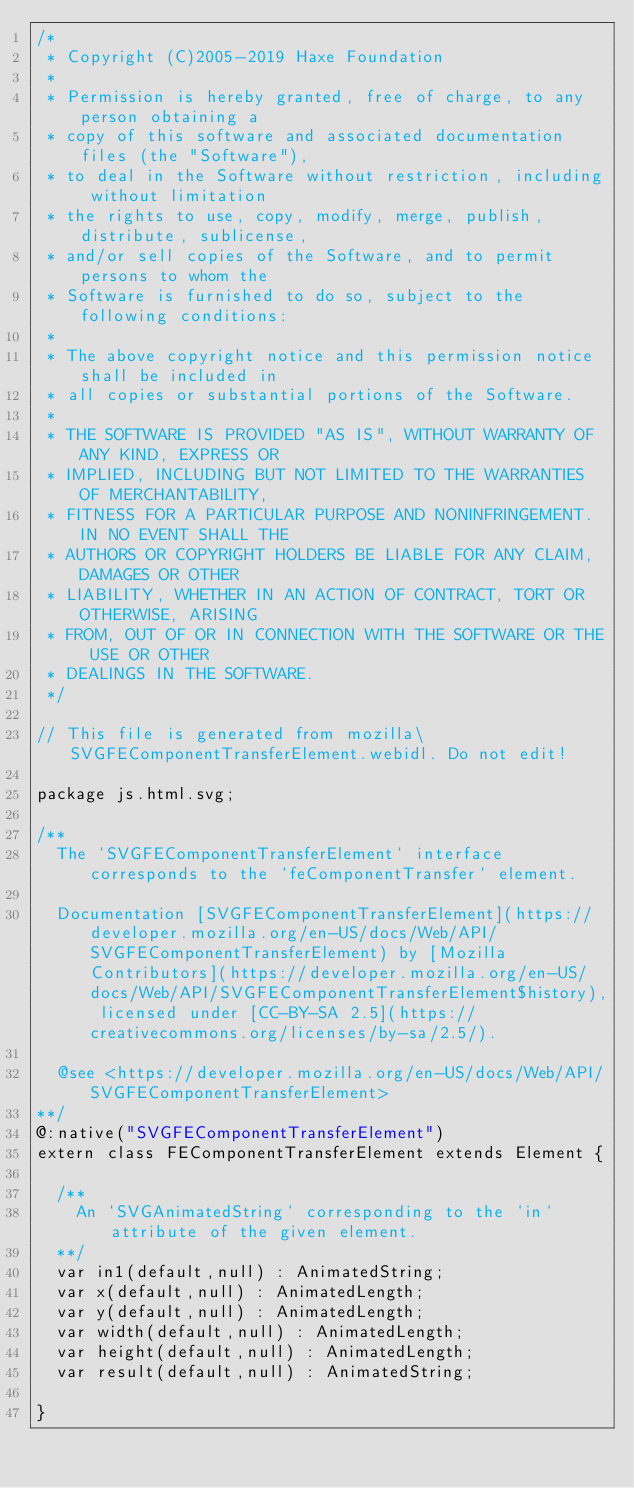Convert code to text. <code><loc_0><loc_0><loc_500><loc_500><_Haxe_>/*
 * Copyright (C)2005-2019 Haxe Foundation
 *
 * Permission is hereby granted, free of charge, to any person obtaining a
 * copy of this software and associated documentation files (the "Software"),
 * to deal in the Software without restriction, including without limitation
 * the rights to use, copy, modify, merge, publish, distribute, sublicense,
 * and/or sell copies of the Software, and to permit persons to whom the
 * Software is furnished to do so, subject to the following conditions:
 *
 * The above copyright notice and this permission notice shall be included in
 * all copies or substantial portions of the Software.
 *
 * THE SOFTWARE IS PROVIDED "AS IS", WITHOUT WARRANTY OF ANY KIND, EXPRESS OR
 * IMPLIED, INCLUDING BUT NOT LIMITED TO THE WARRANTIES OF MERCHANTABILITY,
 * FITNESS FOR A PARTICULAR PURPOSE AND NONINFRINGEMENT. IN NO EVENT SHALL THE
 * AUTHORS OR COPYRIGHT HOLDERS BE LIABLE FOR ANY CLAIM, DAMAGES OR OTHER
 * LIABILITY, WHETHER IN AN ACTION OF CONTRACT, TORT OR OTHERWISE, ARISING
 * FROM, OUT OF OR IN CONNECTION WITH THE SOFTWARE OR THE USE OR OTHER
 * DEALINGS IN THE SOFTWARE.
 */

// This file is generated from mozilla\SVGFEComponentTransferElement.webidl. Do not edit!

package js.html.svg;

/**
	The `SVGFEComponentTransferElement` interface corresponds to the `feComponentTransfer` element.

	Documentation [SVGFEComponentTransferElement](https://developer.mozilla.org/en-US/docs/Web/API/SVGFEComponentTransferElement) by [Mozilla Contributors](https://developer.mozilla.org/en-US/docs/Web/API/SVGFEComponentTransferElement$history), licensed under [CC-BY-SA 2.5](https://creativecommons.org/licenses/by-sa/2.5/).

	@see <https://developer.mozilla.org/en-US/docs/Web/API/SVGFEComponentTransferElement>
**/
@:native("SVGFEComponentTransferElement")
extern class FEComponentTransferElement extends Element {
	
	/**
		An `SVGAnimatedString` corresponding to the `in` attribute of the given element.
	**/
	var in1(default,null) : AnimatedString;
	var x(default,null) : AnimatedLength;
	var y(default,null) : AnimatedLength;
	var width(default,null) : AnimatedLength;
	var height(default,null) : AnimatedLength;
	var result(default,null) : AnimatedString;
	
}</code> 